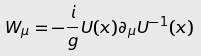<formula> <loc_0><loc_0><loc_500><loc_500>W _ { \mu } = - \frac { i } { g } U ( x ) \partial _ { \mu } U ^ { - 1 } ( x )</formula> 